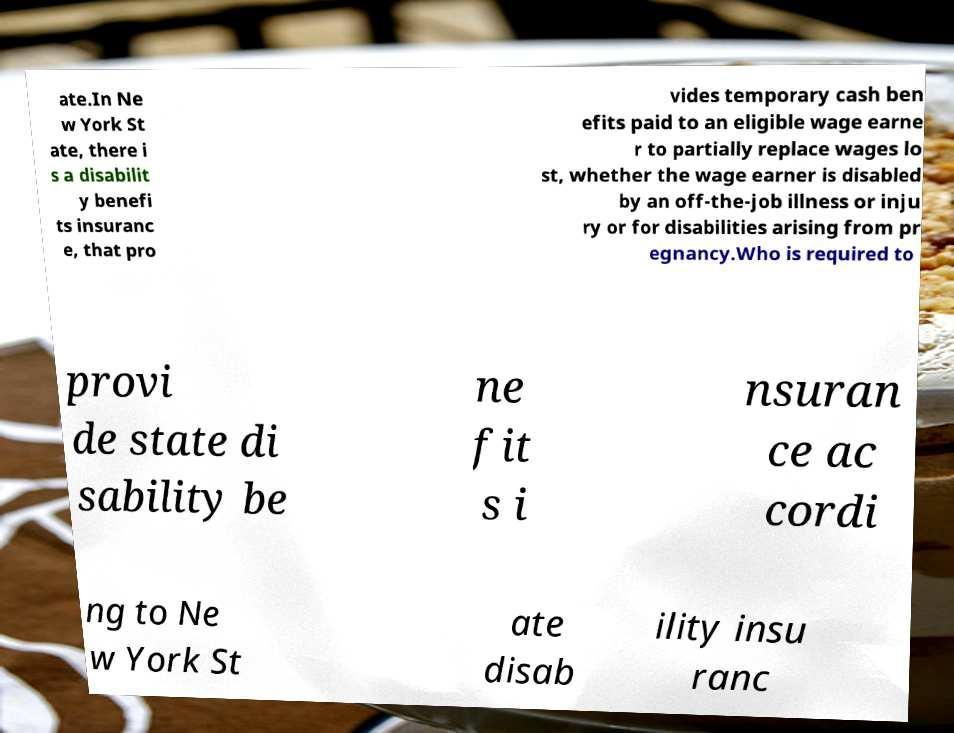Can you accurately transcribe the text from the provided image for me? ate.In Ne w York St ate, there i s a disabilit y benefi ts insuranc e, that pro vides temporary cash ben efits paid to an eligible wage earne r to partially replace wages lo st, whether the wage earner is disabled by an off-the-job illness or inju ry or for disabilities arising from pr egnancy.Who is required to provi de state di sability be ne fit s i nsuran ce ac cordi ng to Ne w York St ate disab ility insu ranc 